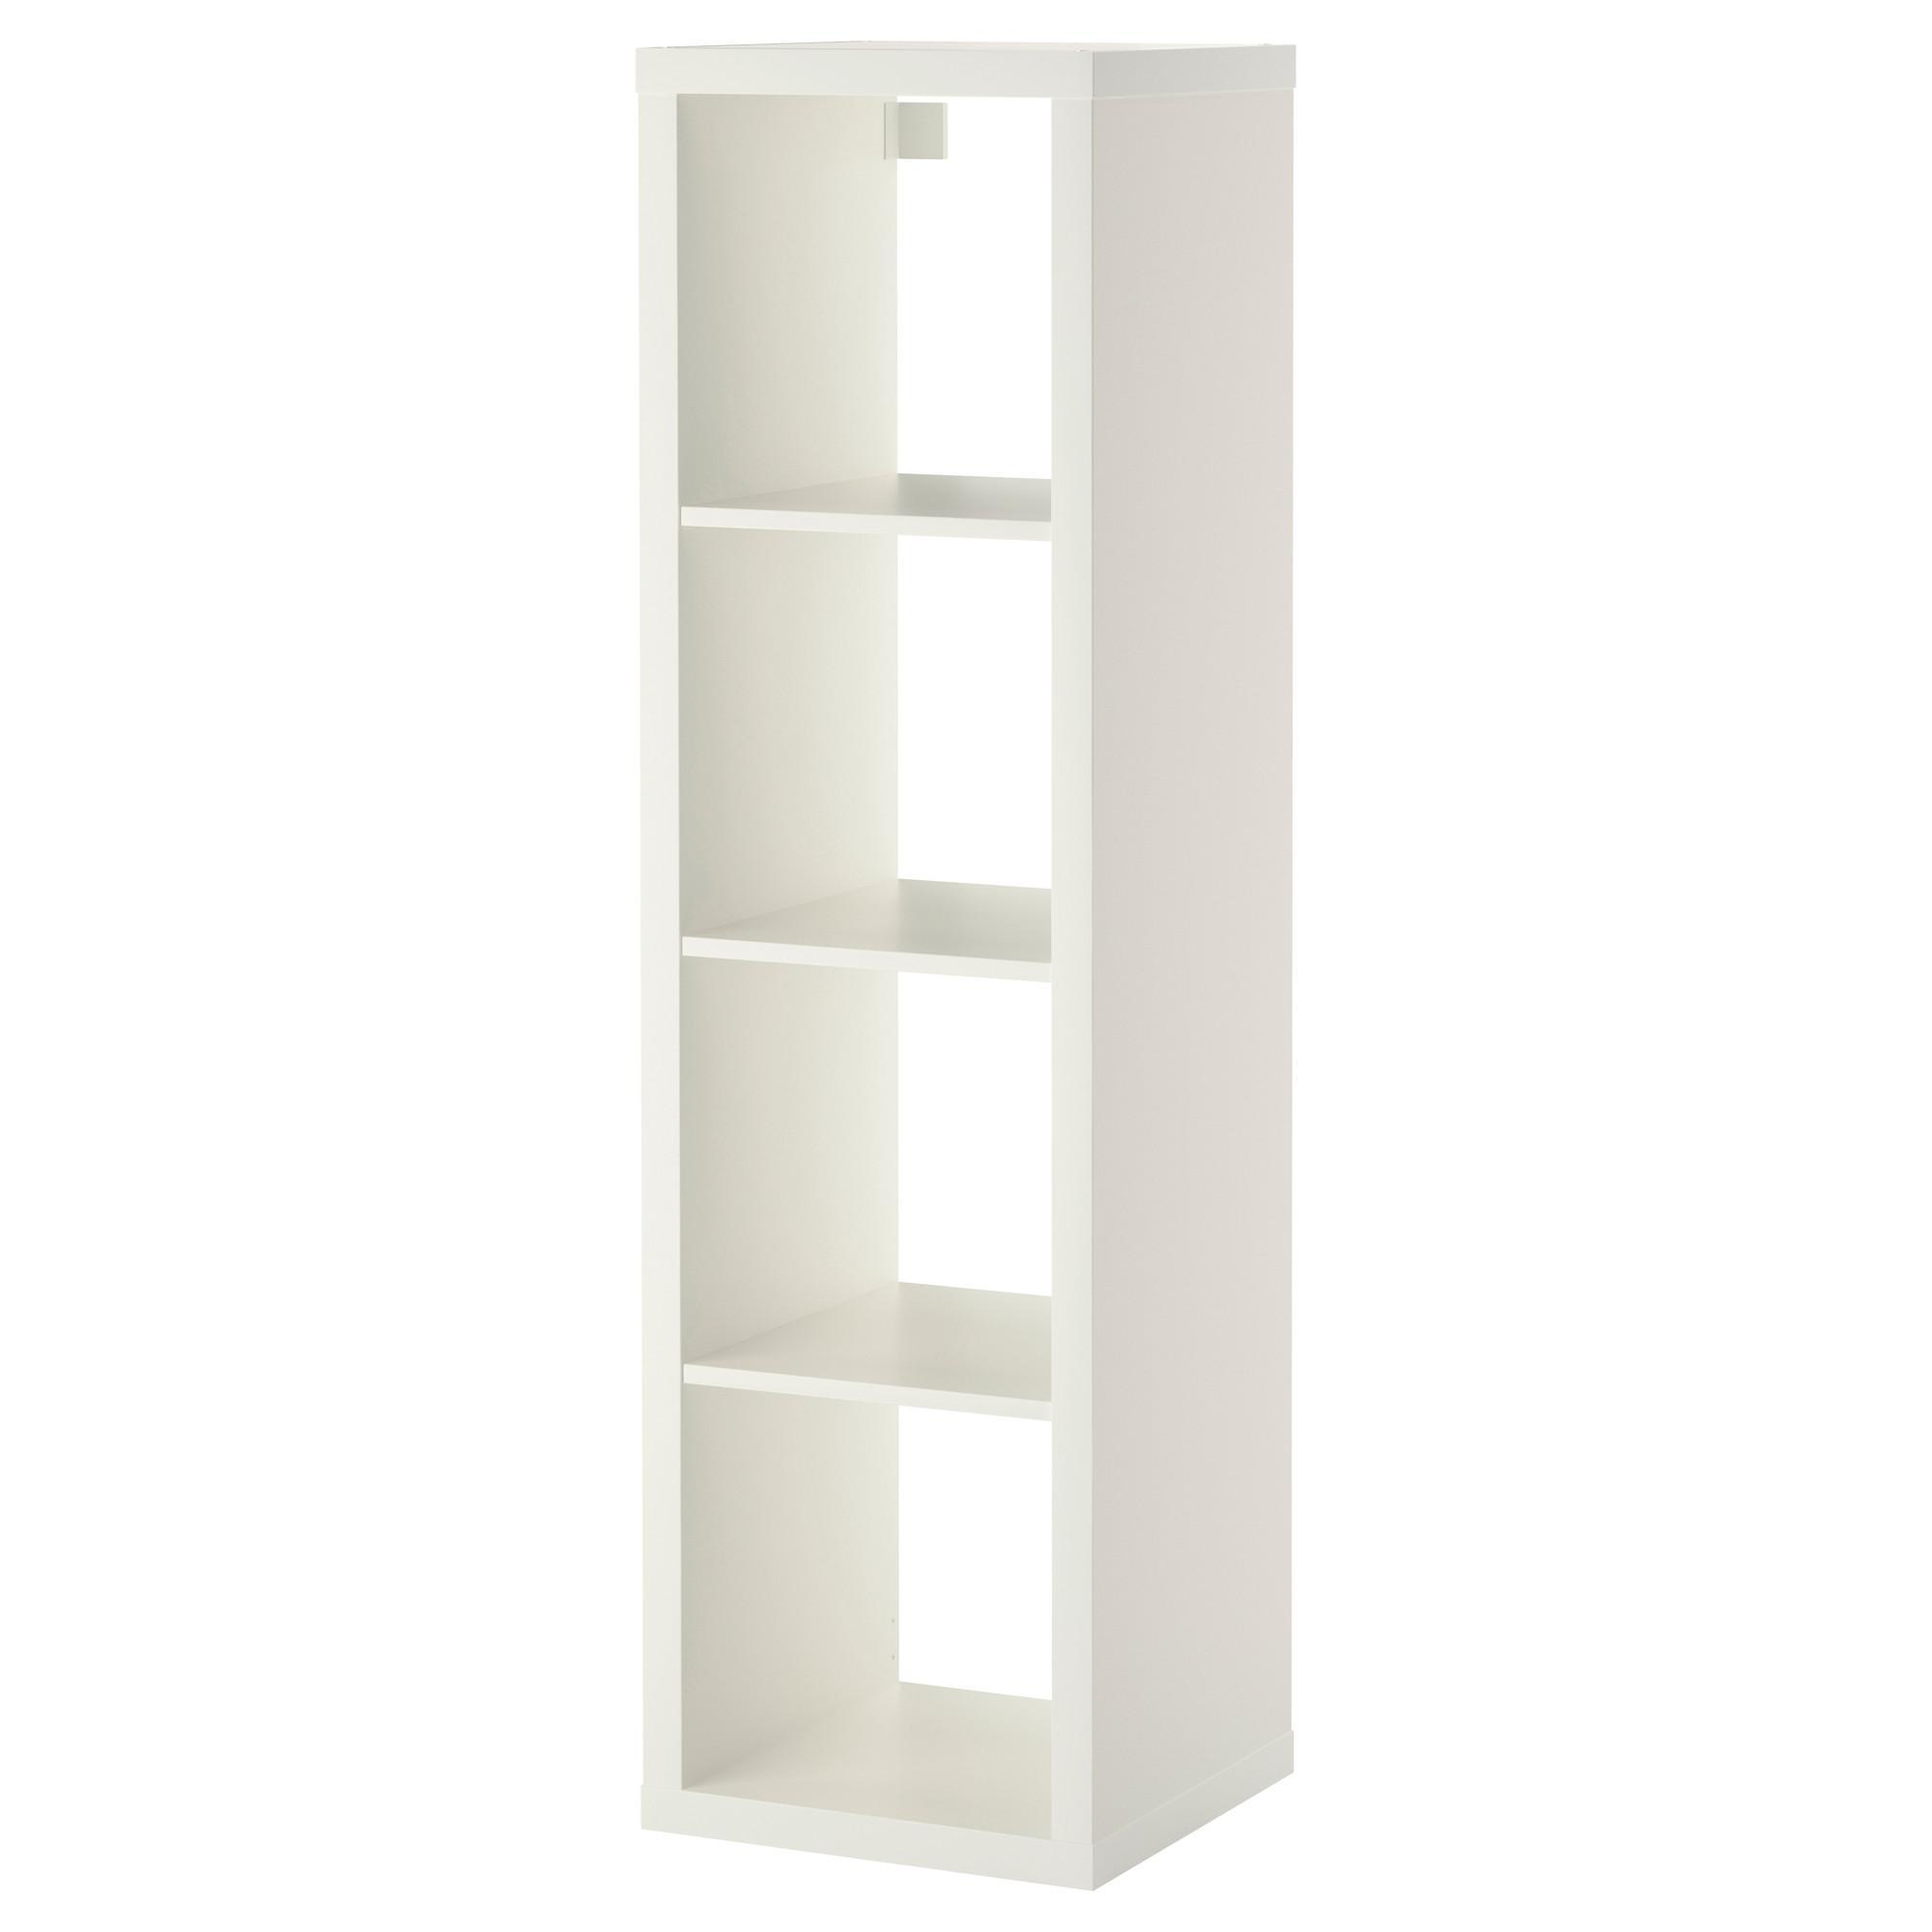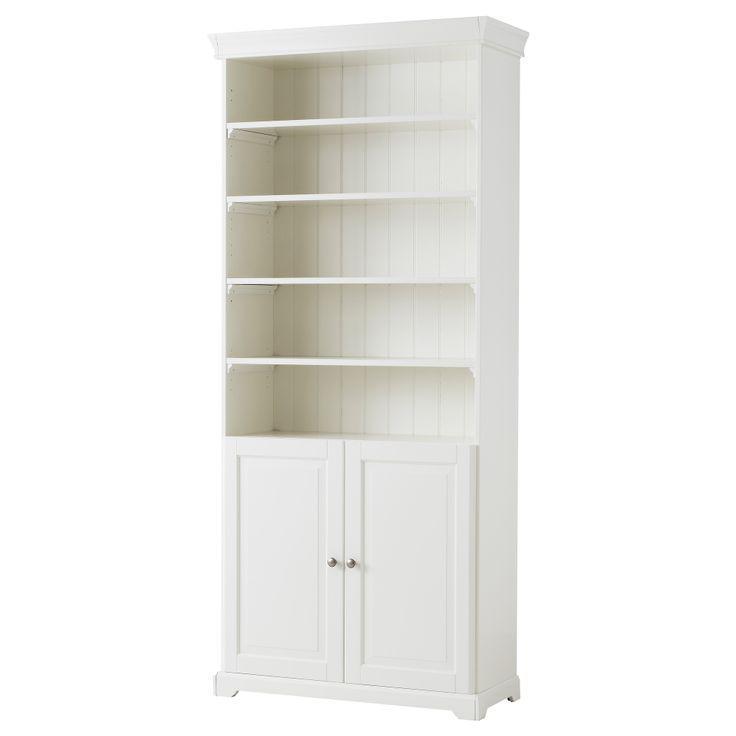The first image is the image on the left, the second image is the image on the right. Evaluate the accuracy of this statement regarding the images: "In the left image, there's a bookcase with a single shelf angled toward the right.". Is it true? Answer yes or no. No. The first image is the image on the left, the second image is the image on the right. Evaluate the accuracy of this statement regarding the images: "Two boxy white bookcases are different sizes, one of them with exactly three shelves and the other with two.". Is it true? Answer yes or no. No. 